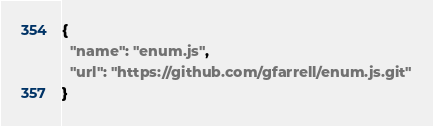Convert code to text. <code><loc_0><loc_0><loc_500><loc_500><_JavaScript_>{
  "name": "enum.js",
  "url": "https://github.com/gfarrell/enum.js.git"
}
</code> 